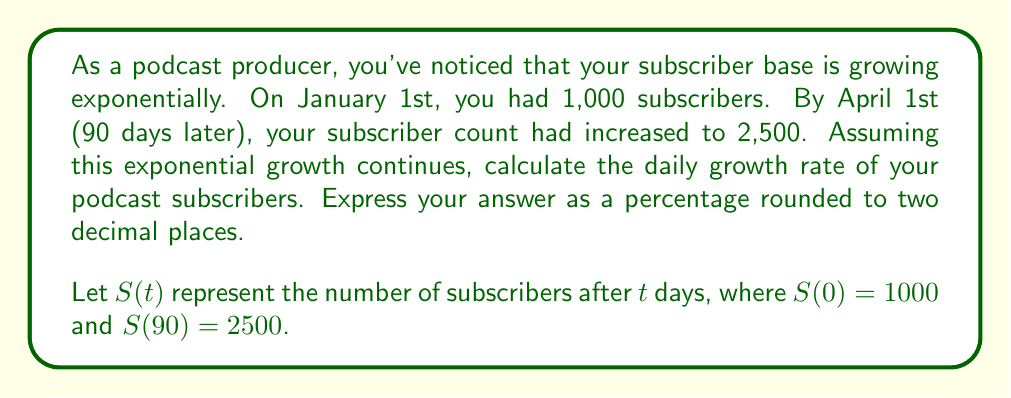Can you answer this question? To solve this problem, we'll use the exponential growth function:

$$S(t) = S_0 \cdot (1 + r)^t$$

Where:
$S(t)$ is the number of subscribers after $t$ days
$S_0$ is the initial number of subscribers
$r$ is the daily growth rate (in decimal form)
$t$ is the number of days

We know:
$S_0 = 1000$
$S(90) = 2500$
$t = 90$

Let's substitute these values into the equation:

$$2500 = 1000 \cdot (1 + r)^{90}$$

Dividing both sides by 1000:

$$2.5 = (1 + r)^{90}$$

Now, we need to solve for $r$. Let's take the 90th root of both sides:

$$\sqrt[90]{2.5} = 1 + r$$

$$\sqrt[90]{2.5} - 1 = r$$

Using a calculator:

$$r \approx 0.01016$$

To convert this to a percentage, we multiply by 100:

$$r \approx 1.016\%$$

Rounding to two decimal places:

$$r \approx 1.02\%$$

This means the podcast subscribers are growing at a rate of approximately 1.02% per day.
Answer: 1.02% 